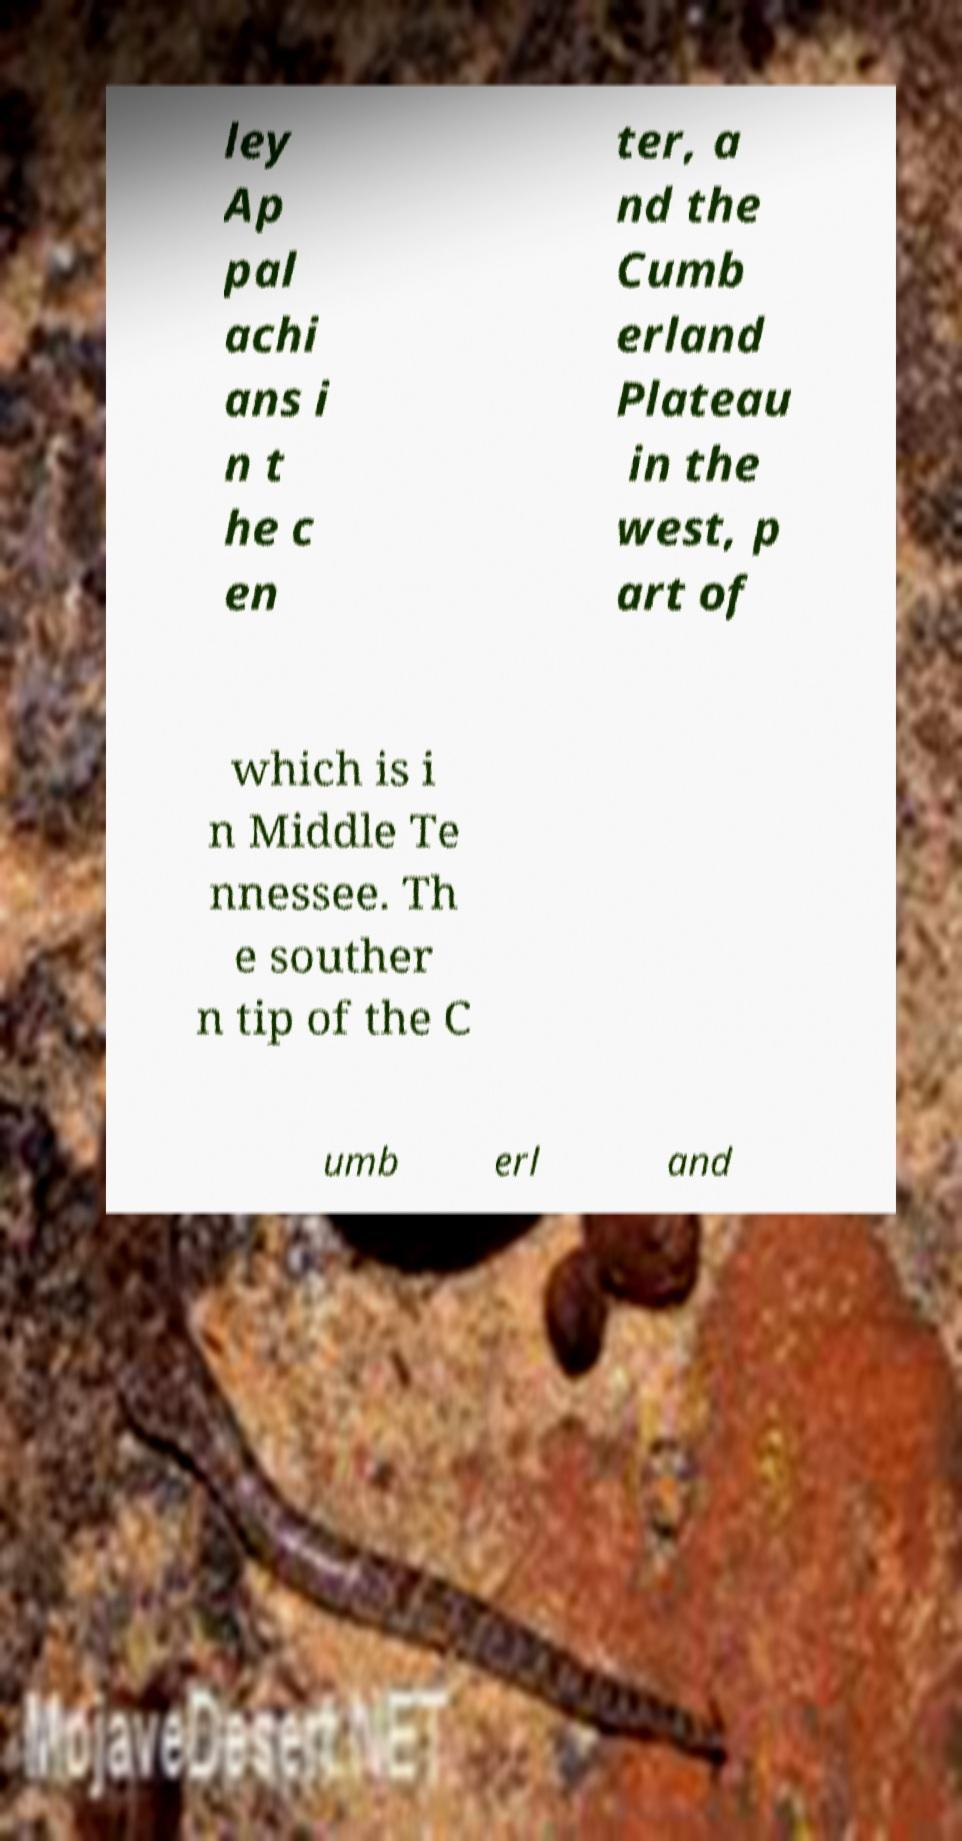Could you assist in decoding the text presented in this image and type it out clearly? ley Ap pal achi ans i n t he c en ter, a nd the Cumb erland Plateau in the west, p art of which is i n Middle Te nnessee. Th e souther n tip of the C umb erl and 